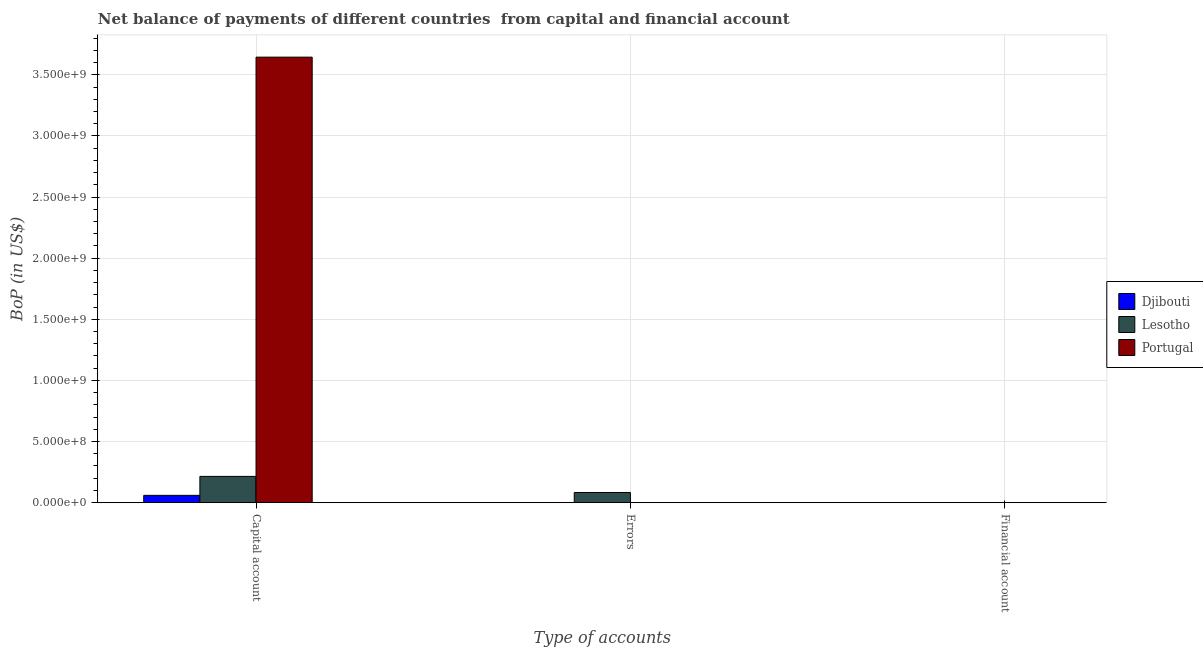How many different coloured bars are there?
Offer a terse response. 3. Are the number of bars on each tick of the X-axis equal?
Offer a terse response. No. How many bars are there on the 1st tick from the left?
Offer a very short reply. 3. How many bars are there on the 1st tick from the right?
Offer a terse response. 0. What is the label of the 3rd group of bars from the left?
Offer a terse response. Financial account. What is the amount of errors in Djibouti?
Provide a succinct answer. 0. Across all countries, what is the maximum amount of net capital account?
Ensure brevity in your answer.  3.64e+09. Across all countries, what is the minimum amount of financial account?
Give a very brief answer. 0. In which country was the amount of net capital account maximum?
Provide a short and direct response. Portugal. What is the total amount of errors in the graph?
Make the answer very short. 8.31e+07. What is the difference between the amount of net capital account in Portugal and that in Lesotho?
Keep it short and to the point. 3.43e+09. What is the difference between the amount of financial account in Portugal and the amount of errors in Lesotho?
Your answer should be compact. -8.31e+07. What is the average amount of errors per country?
Offer a very short reply. 2.77e+07. What is the difference between the amount of errors and amount of net capital account in Lesotho?
Your answer should be compact. -1.32e+08. In how many countries, is the amount of net capital account greater than 3000000000 US$?
Your response must be concise. 1. What is the ratio of the amount of net capital account in Portugal to that in Lesotho?
Offer a very short reply. 16.97. What is the difference between the highest and the second highest amount of net capital account?
Provide a succinct answer. 3.43e+09. What is the difference between the highest and the lowest amount of net capital account?
Keep it short and to the point. 3.59e+09. Is it the case that in every country, the sum of the amount of net capital account and amount of errors is greater than the amount of financial account?
Ensure brevity in your answer.  Yes. How many bars are there?
Your answer should be compact. 4. What is the difference between two consecutive major ticks on the Y-axis?
Provide a short and direct response. 5.00e+08. Are the values on the major ticks of Y-axis written in scientific E-notation?
Keep it short and to the point. Yes. Does the graph contain grids?
Give a very brief answer. Yes. Where does the legend appear in the graph?
Offer a very short reply. Center right. How are the legend labels stacked?
Ensure brevity in your answer.  Vertical. What is the title of the graph?
Ensure brevity in your answer.  Net balance of payments of different countries  from capital and financial account. Does "Chad" appear as one of the legend labels in the graph?
Keep it short and to the point. No. What is the label or title of the X-axis?
Ensure brevity in your answer.  Type of accounts. What is the label or title of the Y-axis?
Offer a terse response. BoP (in US$). What is the BoP (in US$) in Djibouti in Capital account?
Make the answer very short. 5.97e+07. What is the BoP (in US$) of Lesotho in Capital account?
Your answer should be very brief. 2.15e+08. What is the BoP (in US$) of Portugal in Capital account?
Offer a very short reply. 3.64e+09. What is the BoP (in US$) in Lesotho in Errors?
Your answer should be very brief. 8.31e+07. What is the BoP (in US$) of Portugal in Errors?
Give a very brief answer. 0. Across all Type of accounts, what is the maximum BoP (in US$) in Djibouti?
Offer a very short reply. 5.97e+07. Across all Type of accounts, what is the maximum BoP (in US$) in Lesotho?
Your response must be concise. 2.15e+08. Across all Type of accounts, what is the maximum BoP (in US$) in Portugal?
Ensure brevity in your answer.  3.64e+09. Across all Type of accounts, what is the minimum BoP (in US$) in Djibouti?
Keep it short and to the point. 0. Across all Type of accounts, what is the minimum BoP (in US$) in Portugal?
Keep it short and to the point. 0. What is the total BoP (in US$) of Djibouti in the graph?
Provide a short and direct response. 5.97e+07. What is the total BoP (in US$) of Lesotho in the graph?
Offer a terse response. 2.98e+08. What is the total BoP (in US$) of Portugal in the graph?
Give a very brief answer. 3.64e+09. What is the difference between the BoP (in US$) of Lesotho in Capital account and that in Errors?
Give a very brief answer. 1.32e+08. What is the difference between the BoP (in US$) in Djibouti in Capital account and the BoP (in US$) in Lesotho in Errors?
Offer a terse response. -2.35e+07. What is the average BoP (in US$) of Djibouti per Type of accounts?
Make the answer very short. 1.99e+07. What is the average BoP (in US$) of Lesotho per Type of accounts?
Offer a terse response. 9.93e+07. What is the average BoP (in US$) of Portugal per Type of accounts?
Make the answer very short. 1.21e+09. What is the difference between the BoP (in US$) in Djibouti and BoP (in US$) in Lesotho in Capital account?
Make the answer very short. -1.55e+08. What is the difference between the BoP (in US$) of Djibouti and BoP (in US$) of Portugal in Capital account?
Your response must be concise. -3.59e+09. What is the difference between the BoP (in US$) of Lesotho and BoP (in US$) of Portugal in Capital account?
Provide a succinct answer. -3.43e+09. What is the ratio of the BoP (in US$) of Lesotho in Capital account to that in Errors?
Offer a terse response. 2.58. What is the difference between the highest and the lowest BoP (in US$) of Djibouti?
Keep it short and to the point. 5.97e+07. What is the difference between the highest and the lowest BoP (in US$) in Lesotho?
Offer a terse response. 2.15e+08. What is the difference between the highest and the lowest BoP (in US$) of Portugal?
Provide a succinct answer. 3.64e+09. 